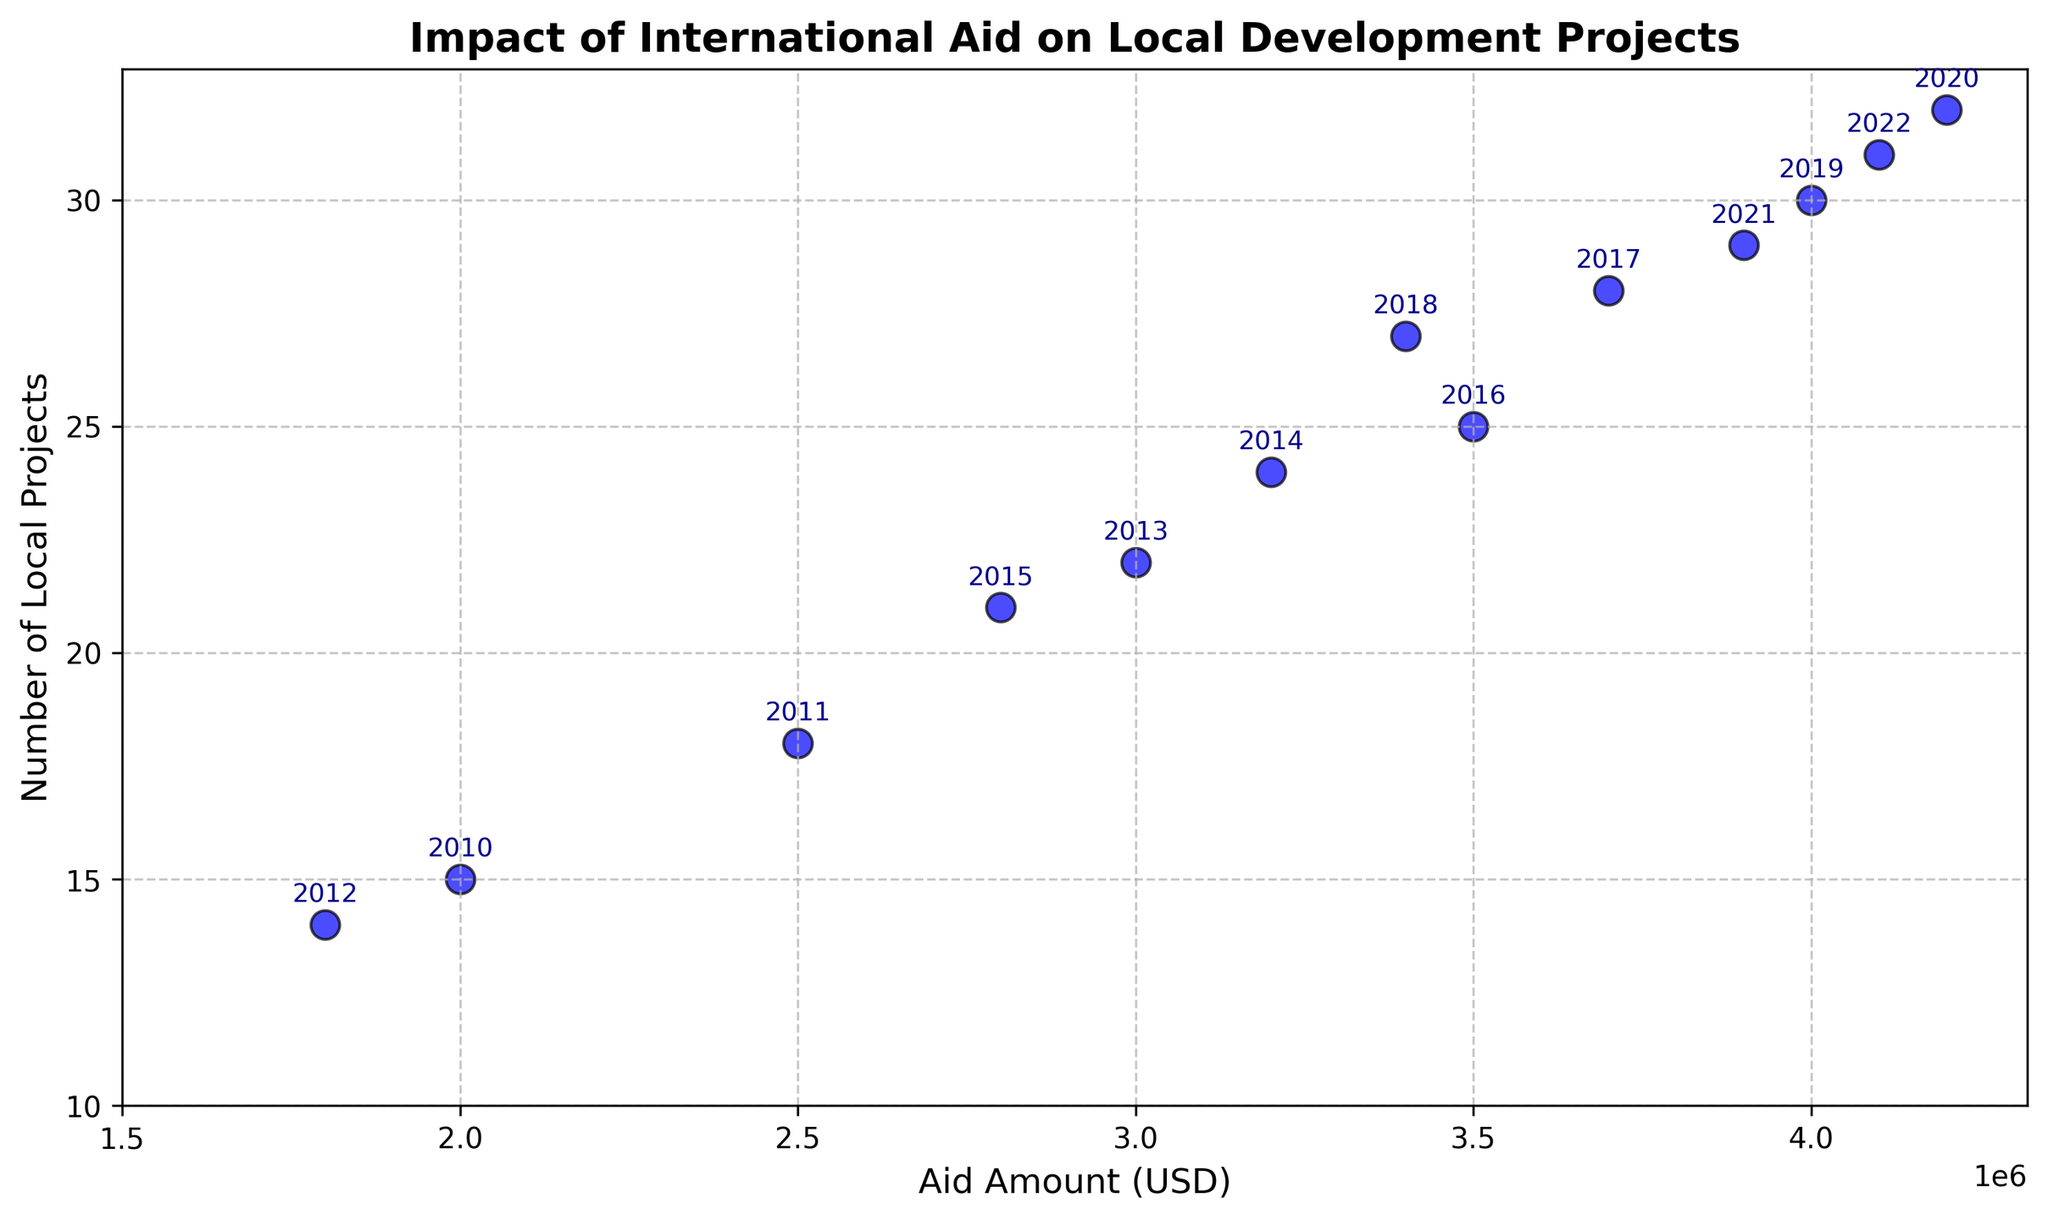What is the overall trend of the number of local projects as the aid amount increases? The scatter plot shows that as the aid amount increases, the number of local projects also tends to increase. Each point is annotated with the year, and there's a positive correlation visible between the aid amount and the number of projects over the years.
Answer: Positive trend Which year received the highest amount of international aid? To determine this, look for the point farthest to the right on the x-axis (Aid Amount). The year next to this point will represent the highest aid received. For this plot, the furthest point is at USD 4200000, which is labeled 2020.
Answer: 2020 How many more projects were initiated in 2020 compared to 2012? First identify the number of projects for 2020 and 2012 from the points labeled with their years. For 2020, there were 32 projects, and for 2012, there were 14 projects. Subtract the latter from the former: 32 - 14 = 18.
Answer: 18 more projects Which year shows a reduction in the number of projects despite receiving a relatively high amount of aid compared to the surrounding years? Looking for a downward anomaly visually, 2021 stands out. Though it received about USD 3900000, the number of projects (29) was less compared to 2020 (32) and 2022 (31).
Answer: 2021 What is the average amount of aid received from 2018 to 2022? First, find the aid amounts from 2018, 2019, 2020, 2021, and 2022. These are USD 3400000, USD 4000000, USD 4200000, USD 3900000, and USD 4100000, respectively. Add these values: 3400000 + 4000000 + 4200000 + 3900000 + 4100000 = 19600000. Then, divide by the number of years (5) to find the average: 19600000 / 5 = 3920000.
Answer: USD 3920000 Which year had the lowest number of projects, and what was the aid amount that year? To find the lowest number of projects, look for the point lowest on the y-axis. The point for 2012 has the lowest number of projects (14). The aid amount for that year was USD 1800000.
Answer: 2012, USD 1800000 What is the maximum number of local projects recorded in any year, and what was the aid amount for that year? Look for the point highest on the y-axis. The point for 2020 has the maximum number of local projects (32). The aid amount for that year was USD 4200000.
Answer: 32 projects, USD 4200000 How does the number of projects in 2014 compare to the number in 2017? From the plot, the number of projects in 2014 is 24, and in 2017 it is 28. 28 - 24 = 4 more projects in 2017 than in 2014.
Answer: 4 more projects What is the median number of local projects over the years 2010–2022? First, list the number of projects in ascending order: 14, 15, 18, 21, 22, 24, 25, 27, 28, 29, 30, 31, 32. To find the median, locate the middle value in this ordered list, which is the 7th value: 25.
Answer: 25 